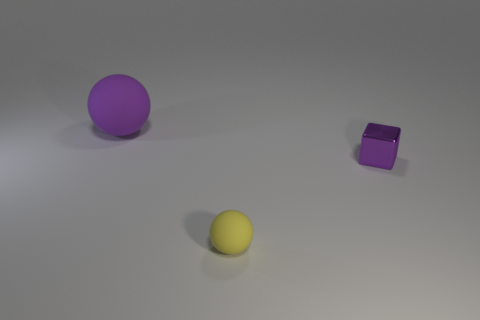What number of cylinders are either large things or purple things?
Offer a very short reply. 0. There is a big object that is the same color as the tiny shiny thing; what is its material?
Ensure brevity in your answer.  Rubber. Do the object behind the block and the tiny thing that is to the right of the tiny rubber object have the same shape?
Provide a succinct answer. No. The thing that is both in front of the large ball and left of the purple metal thing is what color?
Offer a terse response. Yellow. There is a small matte ball; does it have the same color as the matte sphere behind the metallic object?
Provide a short and direct response. No. What is the size of the thing that is both on the left side of the small metal cube and right of the big purple matte object?
Provide a succinct answer. Small. How many other objects are there of the same color as the shiny thing?
Offer a terse response. 1. There is a rubber ball that is on the right side of the matte sphere left of the matte ball in front of the big purple thing; what is its size?
Give a very brief answer. Small. Are there any large purple matte objects on the right side of the tiny metallic cube?
Your answer should be very brief. No. There is a purple matte sphere; is it the same size as the thing that is to the right of the small ball?
Provide a short and direct response. No. 